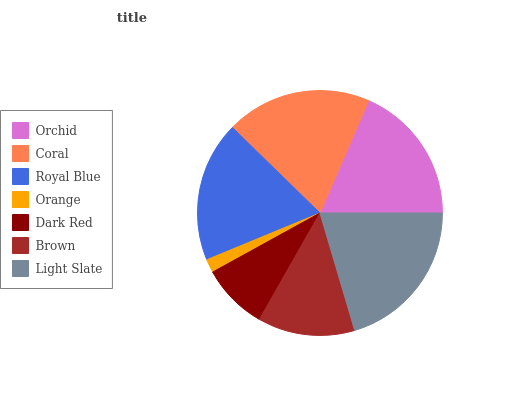Is Orange the minimum?
Answer yes or no. Yes. Is Light Slate the maximum?
Answer yes or no. Yes. Is Coral the minimum?
Answer yes or no. No. Is Coral the maximum?
Answer yes or no. No. Is Coral greater than Orchid?
Answer yes or no. Yes. Is Orchid less than Coral?
Answer yes or no. Yes. Is Orchid greater than Coral?
Answer yes or no. No. Is Coral less than Orchid?
Answer yes or no. No. Is Orchid the high median?
Answer yes or no. Yes. Is Orchid the low median?
Answer yes or no. Yes. Is Coral the high median?
Answer yes or no. No. Is Light Slate the low median?
Answer yes or no. No. 